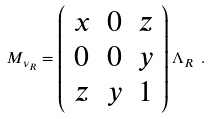Convert formula to latex. <formula><loc_0><loc_0><loc_500><loc_500>M _ { \nu _ { R } } = \left ( \begin{array} { c c c } x & 0 & z \\ 0 & 0 & y \\ z & y & 1 \end{array} \right ) \Lambda _ { R } \ .</formula> 